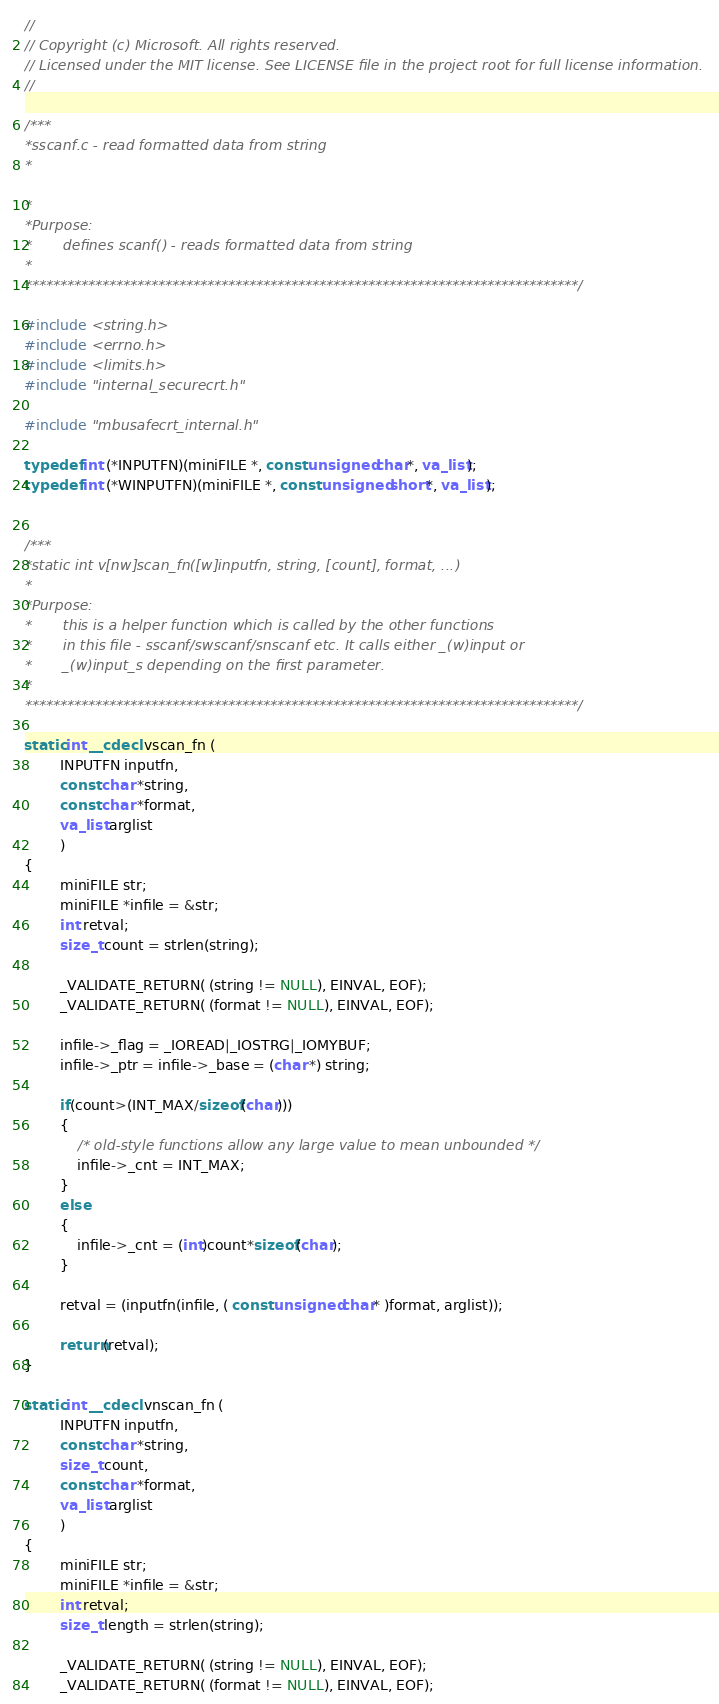Convert code to text. <code><loc_0><loc_0><loc_500><loc_500><_C_>//
// Copyright (c) Microsoft. All rights reserved.
// Licensed under the MIT license. See LICENSE file in the project root for full license information. 
//

/***
*sscanf.c - read formatted data from string
*

*
*Purpose:
*       defines scanf() - reads formatted data from string
*
*******************************************************************************/

#include <string.h>
#include <errno.h>
#include <limits.h>
#include "internal_securecrt.h"

#include "mbusafecrt_internal.h"

typedef int (*INPUTFN)(miniFILE *, const unsigned char*, va_list);
typedef int (*WINPUTFN)(miniFILE *, const unsigned short*, va_list);


/***
*static int v[nw]scan_fn([w]inputfn, string, [count], format, ...)
*
*Purpose:
*       this is a helper function which is called by the other functions
*       in this file - sscanf/swscanf/snscanf etc. It calls either _(w)input or
*       _(w)input_s depending on the first parameter.
*
*******************************************************************************/

static int __cdecl vscan_fn (
        INPUTFN inputfn,
        const char *string,
        const char *format,
        va_list arglist
        )
{
        miniFILE str;
        miniFILE *infile = &str;
        int retval;
        size_t count = strlen(string);

        _VALIDATE_RETURN( (string != NULL), EINVAL, EOF);
        _VALIDATE_RETURN( (format != NULL), EINVAL, EOF);

        infile->_flag = _IOREAD|_IOSTRG|_IOMYBUF;
        infile->_ptr = infile->_base = (char *) string;

        if(count>(INT_MAX/sizeof(char)))
        {
            /* old-style functions allow any large value to mean unbounded */
            infile->_cnt = INT_MAX;
        }
        else
        {
            infile->_cnt = (int)count*sizeof(char);
        }

        retval = (inputfn(infile, ( const unsigned char* )format, arglist));

        return(retval);
}

static int __cdecl vnscan_fn (
        INPUTFN inputfn,
        const char *string,
        size_t count,
        const char *format,
        va_list arglist
        )
{
        miniFILE str;
        miniFILE *infile = &str;
        int retval;
        size_t length = strlen(string);

        _VALIDATE_RETURN( (string != NULL), EINVAL, EOF);
        _VALIDATE_RETURN( (format != NULL), EINVAL, EOF);
</code> 